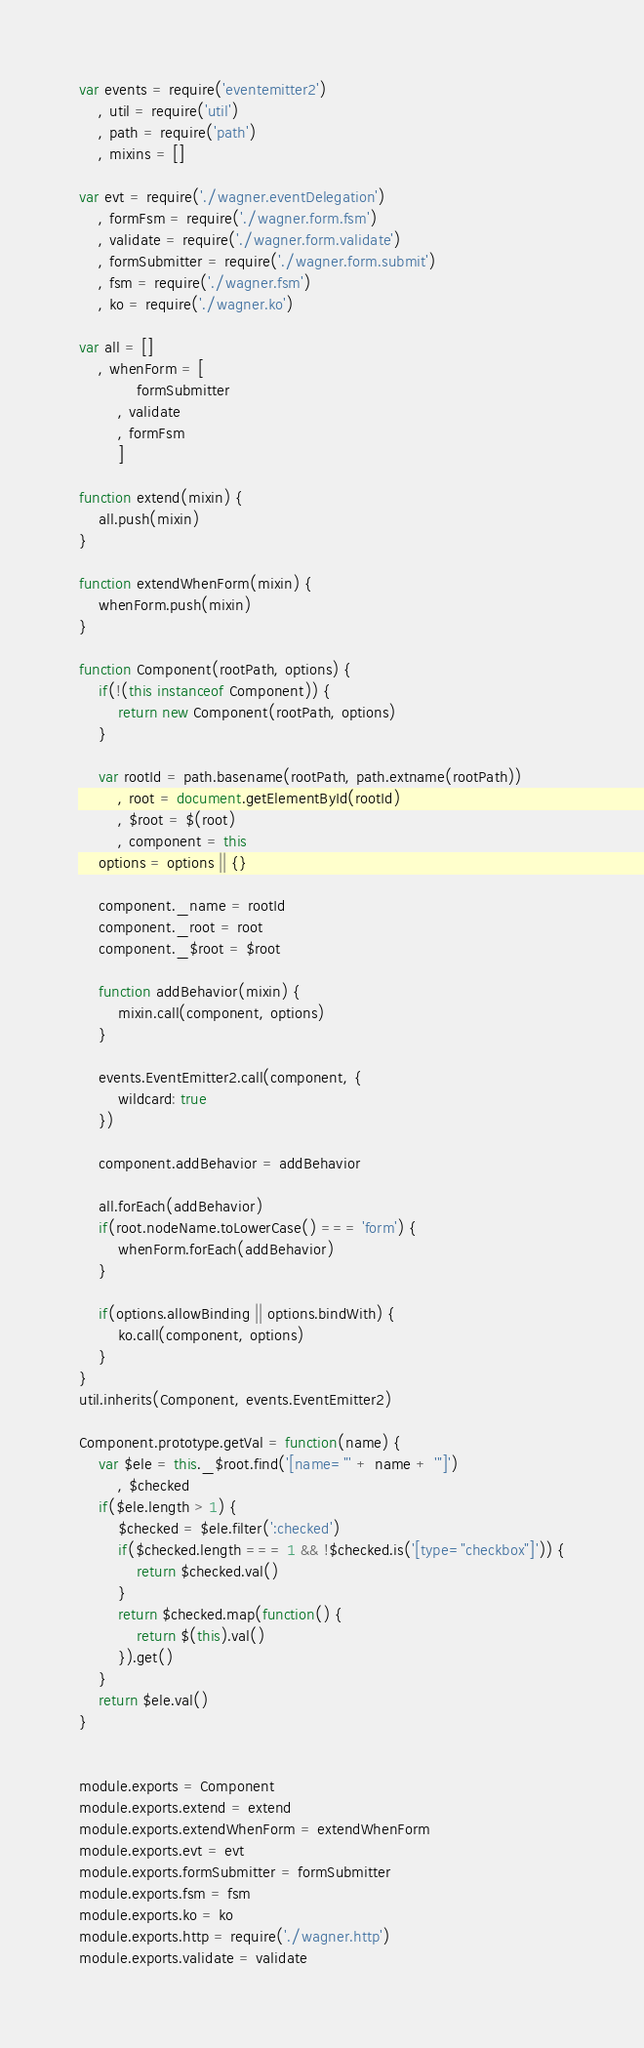<code> <loc_0><loc_0><loc_500><loc_500><_JavaScript_>var events = require('eventemitter2')
	, util = require('util')
	, path = require('path')
	, mixins = []

var evt = require('./wagner.eventDelegation')
	, formFsm = require('./wagner.form.fsm')
	, validate = require('./wagner.form.validate')
	, formSubmitter = require('./wagner.form.submit')
	, fsm = require('./wagner.fsm')
	, ko = require('./wagner.ko')

var all = []
	, whenForm = [
			formSubmitter
		, validate
		, formFsm
		]

function extend(mixin) {
	all.push(mixin)
}

function extendWhenForm(mixin) {
	whenForm.push(mixin)
}

function Component(rootPath, options) {
	if(!(this instanceof Component)) {
		return new Component(rootPath, options)
	}

	var rootId = path.basename(rootPath, path.extname(rootPath))
		, root = document.getElementById(rootId)
		, $root = $(root)
		, component = this
	options = options || {}

	component._name = rootId
	component._root = root
	component._$root = $root

	function addBehavior(mixin) {
		mixin.call(component, options)
	}

	events.EventEmitter2.call(component, {
		wildcard: true
	})

	component.addBehavior = addBehavior

	all.forEach(addBehavior)
	if(root.nodeName.toLowerCase() === 'form') {
		whenForm.forEach(addBehavior)
	}

	if(options.allowBinding || options.bindWith) {
		ko.call(component, options)
	}
}
util.inherits(Component, events.EventEmitter2)

Component.prototype.getVal = function(name) {
	var $ele = this._$root.find('[name="' + name + '"]')	
		, $checked
	if($ele.length > 1) {
		$checked = $ele.filter(':checked')
		if($checked.length === 1 && !$checked.is('[type="checkbox"]')) {
			return $checked.val()
		}
		return $checked.map(function() {
			return $(this).val()
		}).get()
	}
	return $ele.val()
}


module.exports = Component
module.exports.extend = extend
module.exports.extendWhenForm = extendWhenForm
module.exports.evt = evt
module.exports.formSubmitter = formSubmitter
module.exports.fsm = fsm
module.exports.ko = ko
module.exports.http = require('./wagner.http')
module.exports.validate = validate
</code> 